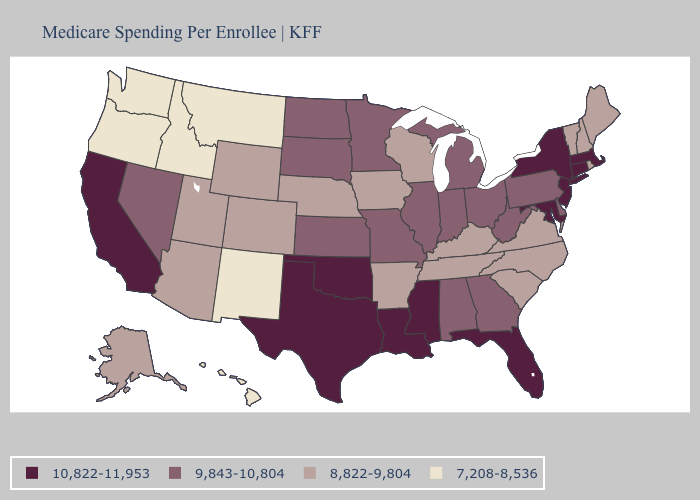What is the value of Alaska?
Be succinct. 8,822-9,804. Does California have the highest value in the West?
Be succinct. Yes. What is the value of Vermont?
Short answer required. 8,822-9,804. What is the value of West Virginia?
Be succinct. 9,843-10,804. What is the value of Michigan?
Write a very short answer. 9,843-10,804. What is the value of Louisiana?
Concise answer only. 10,822-11,953. What is the value of Utah?
Be succinct. 8,822-9,804. Does Pennsylvania have a lower value than Massachusetts?
Concise answer only. Yes. What is the value of North Dakota?
Write a very short answer. 9,843-10,804. What is the value of Kentucky?
Answer briefly. 8,822-9,804. Which states have the lowest value in the USA?
Be succinct. Hawaii, Idaho, Montana, New Mexico, Oregon, Washington. Does North Dakota have the highest value in the MidWest?
Be succinct. Yes. Among the states that border Maryland , does Virginia have the highest value?
Concise answer only. No. Name the states that have a value in the range 7,208-8,536?
Quick response, please. Hawaii, Idaho, Montana, New Mexico, Oregon, Washington. What is the value of Louisiana?
Be succinct. 10,822-11,953. 